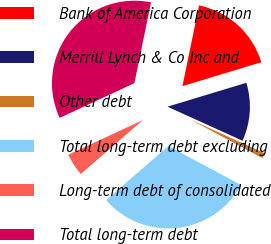Convert chart to OTSL. <chart><loc_0><loc_0><loc_500><loc_500><pie_chart><fcel>Bank of America Corporation<fcel>Merrill Lynch & Co Inc and<fcel>Other debt<fcel>Total long-term debt excluding<fcel>Long-term debt of consolidated<fcel>Total long-term debt<nl><fcel>17.09%<fcel>11.46%<fcel>1.04%<fcel>30.8%<fcel>4.45%<fcel>35.17%<nl></chart> 